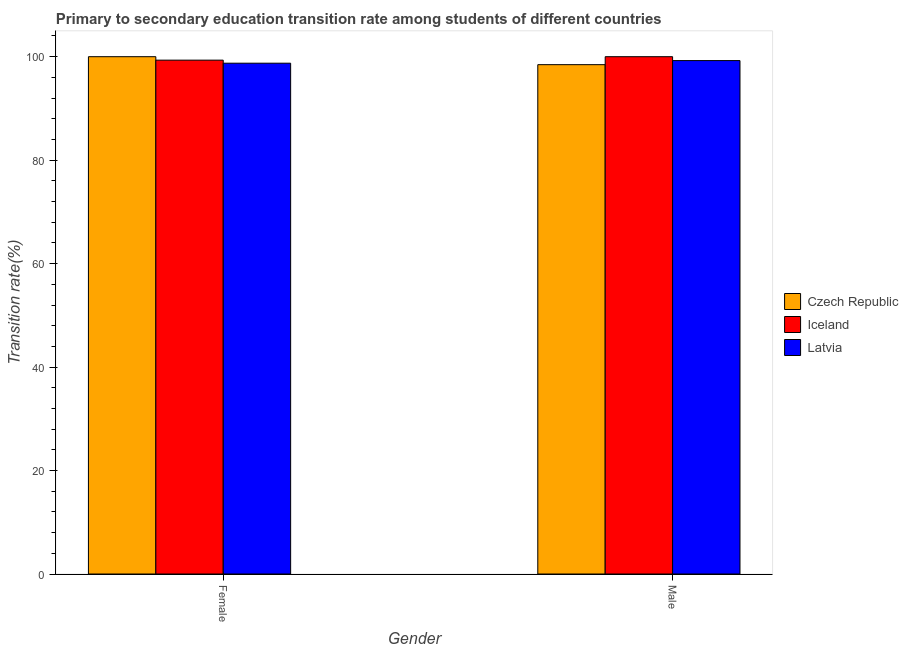How many different coloured bars are there?
Your response must be concise. 3. Are the number of bars per tick equal to the number of legend labels?
Your answer should be compact. Yes. How many bars are there on the 2nd tick from the left?
Offer a very short reply. 3. How many bars are there on the 1st tick from the right?
Your answer should be very brief. 3. What is the transition rate among male students in Czech Republic?
Offer a terse response. 98.46. Across all countries, what is the minimum transition rate among male students?
Provide a succinct answer. 98.46. In which country was the transition rate among female students maximum?
Your answer should be compact. Czech Republic. In which country was the transition rate among male students minimum?
Your answer should be compact. Czech Republic. What is the total transition rate among male students in the graph?
Ensure brevity in your answer.  297.71. What is the difference between the transition rate among male students in Latvia and that in Czech Republic?
Offer a very short reply. 0.79. What is the difference between the transition rate among female students in Czech Republic and the transition rate among male students in Latvia?
Provide a succinct answer. 0.75. What is the average transition rate among male students per country?
Make the answer very short. 99.24. What is the difference between the transition rate among female students and transition rate among male students in Czech Republic?
Your answer should be very brief. 1.54. What is the ratio of the transition rate among male students in Latvia to that in Czech Republic?
Your answer should be compact. 1.01. Is the transition rate among male students in Latvia less than that in Czech Republic?
Your response must be concise. No. In how many countries, is the transition rate among male students greater than the average transition rate among male students taken over all countries?
Ensure brevity in your answer.  2. What does the 3rd bar from the left in Male represents?
Provide a succinct answer. Latvia. What does the 1st bar from the right in Male represents?
Ensure brevity in your answer.  Latvia. What is the difference between two consecutive major ticks on the Y-axis?
Keep it short and to the point. 20. Are the values on the major ticks of Y-axis written in scientific E-notation?
Your response must be concise. No. Does the graph contain grids?
Your answer should be very brief. No. Where does the legend appear in the graph?
Keep it short and to the point. Center right. How many legend labels are there?
Offer a very short reply. 3. How are the legend labels stacked?
Provide a short and direct response. Vertical. What is the title of the graph?
Make the answer very short. Primary to secondary education transition rate among students of different countries. Does "Czech Republic" appear as one of the legend labels in the graph?
Ensure brevity in your answer.  Yes. What is the label or title of the X-axis?
Provide a short and direct response. Gender. What is the label or title of the Y-axis?
Offer a very short reply. Transition rate(%). What is the Transition rate(%) of Czech Republic in Female?
Your answer should be compact. 100. What is the Transition rate(%) in Iceland in Female?
Keep it short and to the point. 99.33. What is the Transition rate(%) in Latvia in Female?
Offer a terse response. 98.74. What is the Transition rate(%) of Czech Republic in Male?
Offer a terse response. 98.46. What is the Transition rate(%) in Iceland in Male?
Ensure brevity in your answer.  100. What is the Transition rate(%) of Latvia in Male?
Provide a short and direct response. 99.25. Across all Gender, what is the maximum Transition rate(%) in Czech Republic?
Provide a short and direct response. 100. Across all Gender, what is the maximum Transition rate(%) of Iceland?
Your response must be concise. 100. Across all Gender, what is the maximum Transition rate(%) in Latvia?
Your response must be concise. 99.25. Across all Gender, what is the minimum Transition rate(%) in Czech Republic?
Your answer should be very brief. 98.46. Across all Gender, what is the minimum Transition rate(%) in Iceland?
Your answer should be very brief. 99.33. Across all Gender, what is the minimum Transition rate(%) in Latvia?
Keep it short and to the point. 98.74. What is the total Transition rate(%) in Czech Republic in the graph?
Give a very brief answer. 198.46. What is the total Transition rate(%) in Iceland in the graph?
Keep it short and to the point. 199.33. What is the total Transition rate(%) in Latvia in the graph?
Provide a succinct answer. 197.99. What is the difference between the Transition rate(%) of Czech Republic in Female and that in Male?
Ensure brevity in your answer.  1.54. What is the difference between the Transition rate(%) of Iceland in Female and that in Male?
Offer a very short reply. -0.67. What is the difference between the Transition rate(%) in Latvia in Female and that in Male?
Offer a very short reply. -0.5. What is the difference between the Transition rate(%) of Czech Republic in Female and the Transition rate(%) of Iceland in Male?
Your response must be concise. 0. What is the difference between the Transition rate(%) in Czech Republic in Female and the Transition rate(%) in Latvia in Male?
Provide a short and direct response. 0.75. What is the difference between the Transition rate(%) in Iceland in Female and the Transition rate(%) in Latvia in Male?
Offer a very short reply. 0.08. What is the average Transition rate(%) of Czech Republic per Gender?
Keep it short and to the point. 99.23. What is the average Transition rate(%) of Iceland per Gender?
Provide a short and direct response. 99.67. What is the average Transition rate(%) of Latvia per Gender?
Give a very brief answer. 98.99. What is the difference between the Transition rate(%) in Czech Republic and Transition rate(%) in Iceland in Female?
Your response must be concise. 0.67. What is the difference between the Transition rate(%) of Czech Republic and Transition rate(%) of Latvia in Female?
Give a very brief answer. 1.26. What is the difference between the Transition rate(%) of Iceland and Transition rate(%) of Latvia in Female?
Offer a very short reply. 0.59. What is the difference between the Transition rate(%) of Czech Republic and Transition rate(%) of Iceland in Male?
Make the answer very short. -1.54. What is the difference between the Transition rate(%) of Czech Republic and Transition rate(%) of Latvia in Male?
Make the answer very short. -0.79. What is the difference between the Transition rate(%) of Iceland and Transition rate(%) of Latvia in Male?
Offer a very short reply. 0.75. What is the ratio of the Transition rate(%) of Czech Republic in Female to that in Male?
Your answer should be compact. 1.02. What is the ratio of the Transition rate(%) in Iceland in Female to that in Male?
Your response must be concise. 0.99. What is the difference between the highest and the second highest Transition rate(%) in Czech Republic?
Offer a terse response. 1.54. What is the difference between the highest and the second highest Transition rate(%) of Iceland?
Provide a short and direct response. 0.67. What is the difference between the highest and the second highest Transition rate(%) of Latvia?
Your answer should be compact. 0.5. What is the difference between the highest and the lowest Transition rate(%) of Czech Republic?
Your answer should be compact. 1.54. What is the difference between the highest and the lowest Transition rate(%) of Iceland?
Offer a very short reply. 0.67. What is the difference between the highest and the lowest Transition rate(%) of Latvia?
Offer a very short reply. 0.5. 